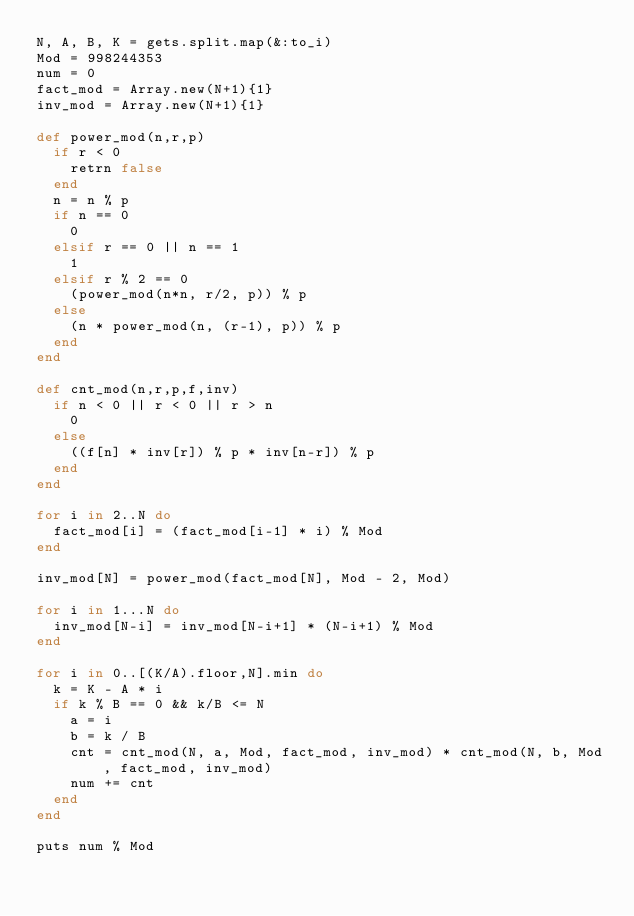<code> <loc_0><loc_0><loc_500><loc_500><_Ruby_>N, A, B, K = gets.split.map(&:to_i)
Mod = 998244353
num = 0
fact_mod = Array.new(N+1){1}
inv_mod = Array.new(N+1){1}

def power_mod(n,r,p)
  if r < 0
    retrn false
  end
  n = n % p
  if n == 0
    0
  elsif r == 0 || n == 1
    1
  elsif r % 2 == 0
    (power_mod(n*n, r/2, p)) % p
  else
    (n * power_mod(n, (r-1), p)) % p
  end
end

def cnt_mod(n,r,p,f,inv)
  if n < 0 || r < 0 || r > n
    0
  else
    ((f[n] * inv[r]) % p * inv[n-r]) % p
  end
end

for i in 2..N do
  fact_mod[i] = (fact_mod[i-1] * i) % Mod
end

inv_mod[N] = power_mod(fact_mod[N], Mod - 2, Mod)

for i in 1...N do
  inv_mod[N-i] = inv_mod[N-i+1] * (N-i+1) % Mod
end

for i in 0..[(K/A).floor,N].min do
  k = K - A * i
  if k % B == 0 && k/B <= N
    a = i
    b = k / B
    cnt = cnt_mod(N, a, Mod, fact_mod, inv_mod) * cnt_mod(N, b, Mod, fact_mod, inv_mod)
    num += cnt
  end
end

puts num % Mod</code> 